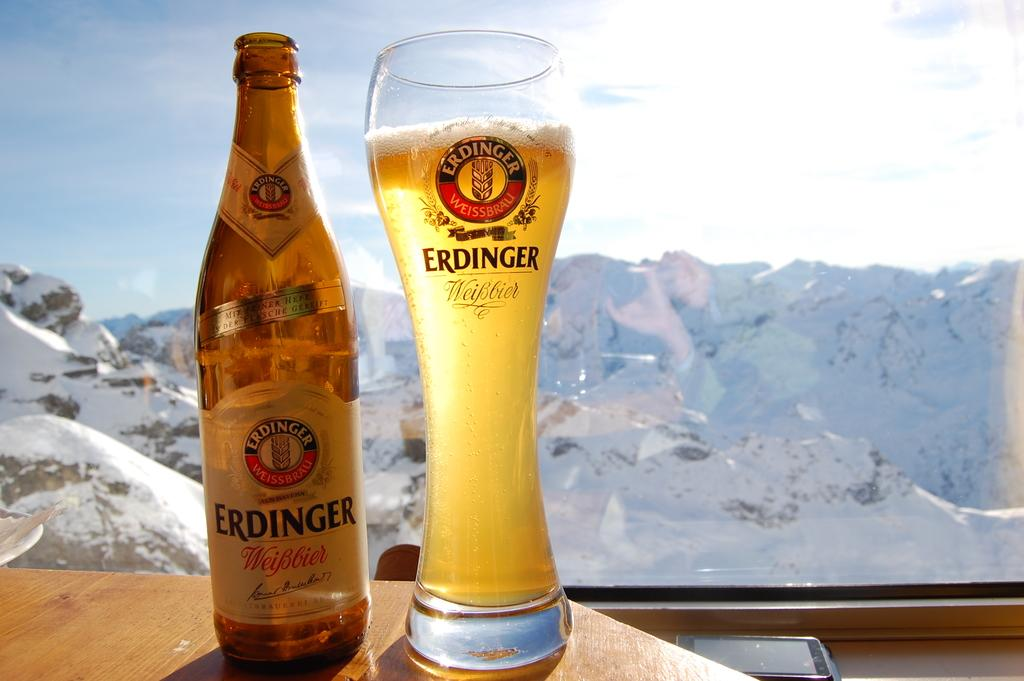<image>
Describe the image concisely. A bottle and a glass of Erdinger alcohol against the backdrop of the snowy mountains. 